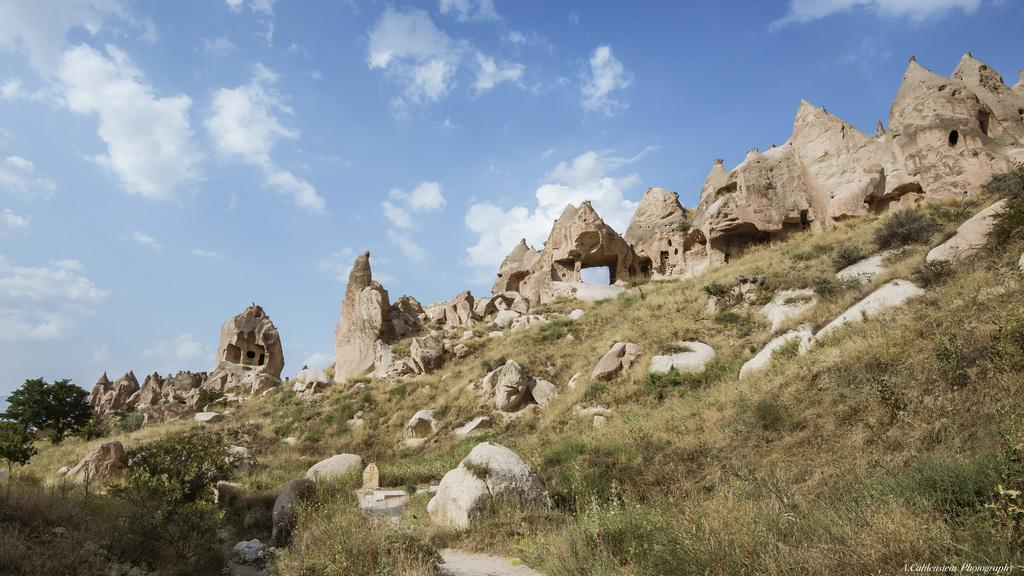What type of vegetation can be seen in the image? There is grass, plants, and trees in the image. What other objects are present in the image? There are rocks and ruins in the image. What is visible in the background of the image? The sky is visible in the background of the image. What can be seen in the sky? There are clouds in the sky. What word is written on the rocks in the image? There are no words written on the rocks in the image. Can you see a goldfish swimming in the grass in the image? There is no goldfish present in the image, and goldfish are not typically found swimming in grass. 